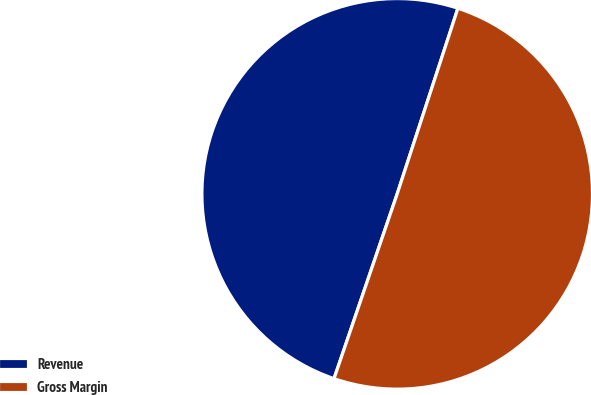Convert chart to OTSL. <chart><loc_0><loc_0><loc_500><loc_500><pie_chart><fcel>Revenue<fcel>Gross Margin<nl><fcel>49.79%<fcel>50.21%<nl></chart> 